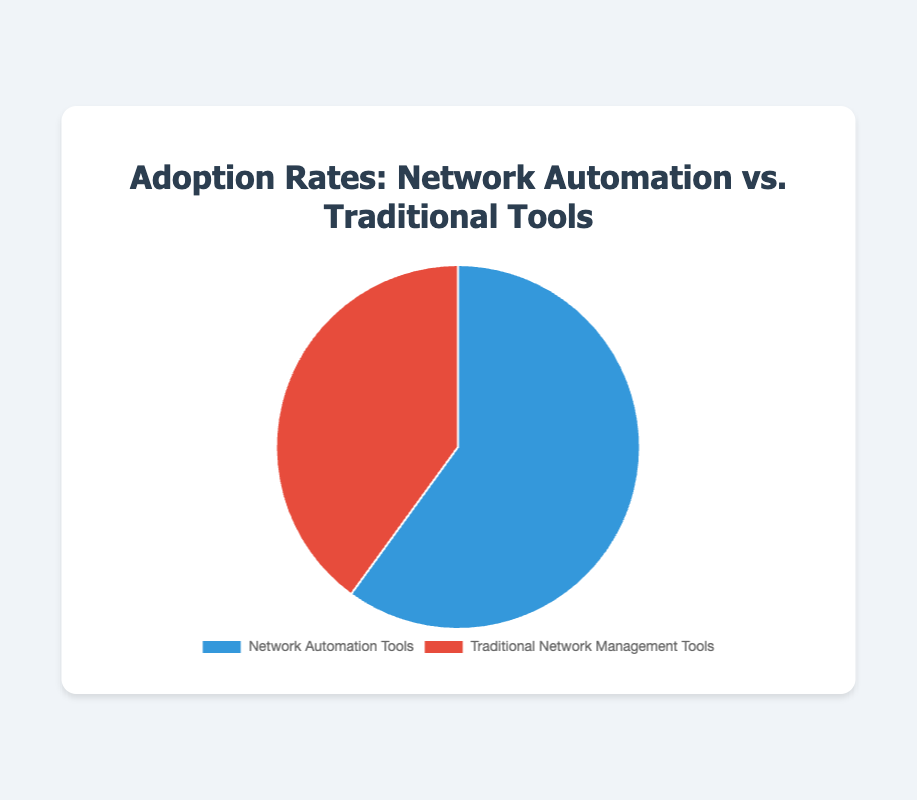What percentage of the chart represents Network Automation Tools? The figure shows that Network Automation Tools account for 60% of the total.
Answer: 60% What is the combined percentage for both Network Automation Tools and Traditional Network Management Tools? Add the percentages for both Network Automation Tools (60%) and Traditional Network Management Tools (40%). So, 60% + 40% = 100%.
Answer: 100% Which category has a greater adoption rate? Compare the two categories, Network Automation Tools (60%) and Traditional Network Management Tools (40%), and see which one is higher.
Answer: Network Automation Tools How much greater is the adoption rate of Network Automation Tools compared to Traditional Network Management Tools? Subtract the percentage of Traditional Network Management Tools (40%) from Network Automation Tools (60%). So, 60% - 40% = 20%.
Answer: 20% If the adoption rate of Network Automation Tools increased by 10%, what would the new percentage be? Add 10% to the current adoption rate of Network Automation Tools, which is 60%. So, 60% + 10% = 70%.
Answer: 70% What colors represent the Network Automation Tools and Traditional Network Management Tools on the chart? The colors can be identified visually from the chart: Network Automation Tools is blue, and Traditional Network Management Tools is red.
Answer: Blue and Red What percentage of the chart is red? The Traditional Network Management Tools, which is red, represents 40% of the chart.
Answer: 40% How many logical operations are needed to find the difference between the two adoption rates? One subtraction operation is needed: 60% - 40% = 20%.
Answer: 1 